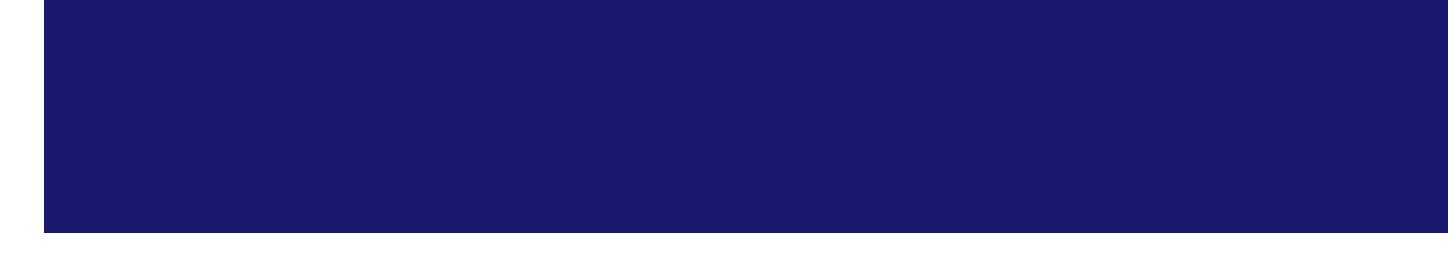What is the billing period? The billing period is stated as the timeframe for which the subscription is active, which is from May 1, 2023 to May 31, 2023.
Answer: May 1, 2023 - May 31, 2023 Who is the account holder? The account holder's name is provided in the invoice details section, which identifies the individual responsible for the account.
Answer: Dr. Sarah Thompson How much is the monthly access fee? The price for the monthly access to the database is included in the subscription items, specifically indicating the cost for that service.
Answer: 79.99 What is the total amount due? The total amount due is calculated as the sum of the subtotal and tax as presented in the payment details section.
Answer: 167.37 How many database queries were made? The number of database queries is listed under usage statistics, providing insight into the usage of the service during the billing period.
Answer: 1875 What feature includes interactive 3D models? This feature is specifically mentioned under additional features, highlighting its educational purpose related to constellations and planetary systems.
Answer: Virtual planetarium access Which payment method was used? The payment method is described in the payment details section, detailing how the invoice was settled.
Answer: Credit Card ending in 4567 When is the monthly webinar scheduled? The date of the monthly webinar is stated in the additional features section, indicating when the event will take place.
Answer: May 15, 2023 How many GB of data were downloaded? The data downloaded is reported in the usage statistics, providing an overview of the data usage during the subscription period.
Answer: 56.2 